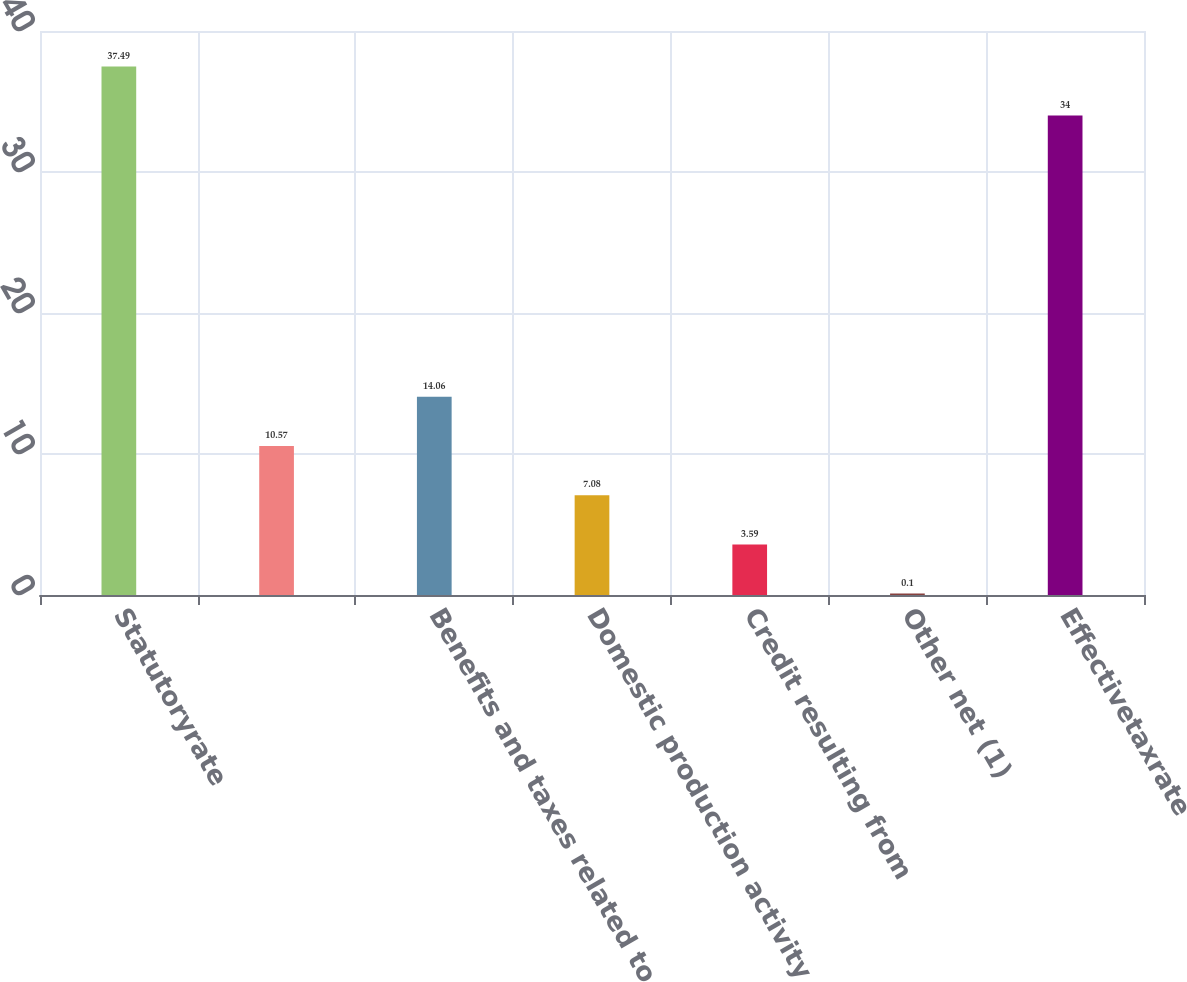<chart> <loc_0><loc_0><loc_500><loc_500><bar_chart><fcel>Statutoryrate<fcel>Unnamed: 1<fcel>Benefits and taxes related to<fcel>Domestic production activity<fcel>Credit resulting from<fcel>Other net (1)<fcel>Effectivetaxrate<nl><fcel>37.49<fcel>10.57<fcel>14.06<fcel>7.08<fcel>3.59<fcel>0.1<fcel>34<nl></chart> 